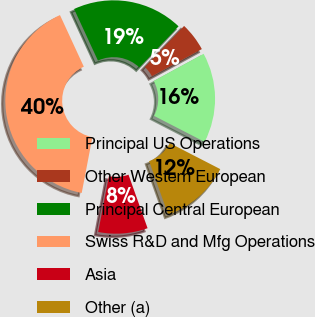<chart> <loc_0><loc_0><loc_500><loc_500><pie_chart><fcel>Principal US Operations<fcel>Other Western European<fcel>Principal Central European<fcel>Swiss R&D and Mfg Operations<fcel>Asia<fcel>Other (a)<nl><fcel>15.5%<fcel>4.95%<fcel>19.01%<fcel>40.09%<fcel>8.47%<fcel>11.98%<nl></chart> 